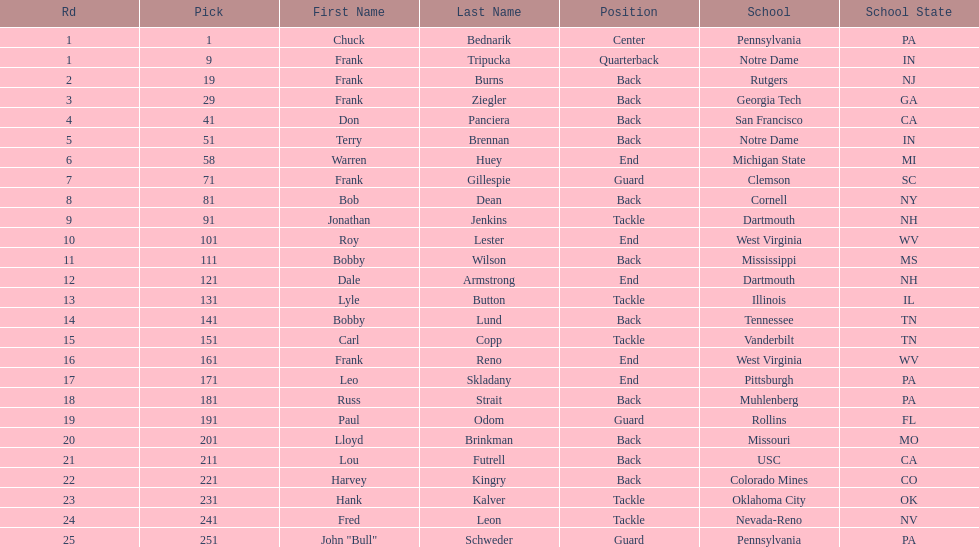Write the full table. {'header': ['Rd', 'Pick', 'First Name', 'Last Name', 'Position', 'School', 'School State'], 'rows': [['1', '1', 'Chuck', 'Bednarik', 'Center', 'Pennsylvania', 'PA'], ['1', '9', 'Frank', 'Tripucka', 'Quarterback', 'Notre Dame', 'IN'], ['2', '19', 'Frank', 'Burns', 'Back', 'Rutgers', 'NJ'], ['3', '29', 'Frank', 'Ziegler', 'Back', 'Georgia Tech', 'GA'], ['4', '41', 'Don', 'Panciera', 'Back', 'San Francisco', 'CA'], ['5', '51', 'Terry', 'Brennan', 'Back', 'Notre Dame', 'IN'], ['6', '58', 'Warren', 'Huey', 'End', 'Michigan State', 'MI'], ['7', '71', 'Frank', 'Gillespie', 'Guard', 'Clemson', 'SC'], ['8', '81', 'Bob', 'Dean', 'Back', 'Cornell', 'NY'], ['9', '91', 'Jonathan', 'Jenkins', 'Tackle', 'Dartmouth', 'NH'], ['10', '101', 'Roy', 'Lester', 'End', 'West Virginia', 'WV'], ['11', '111', 'Bobby', 'Wilson', 'Back', 'Mississippi', 'MS'], ['12', '121', 'Dale', 'Armstrong', 'End', 'Dartmouth', 'NH'], ['13', '131', 'Lyle', 'Button', 'Tackle', 'Illinois', 'IL'], ['14', '141', 'Bobby', 'Lund', 'Back', 'Tennessee', 'TN'], ['15', '151', 'Carl', 'Copp', 'Tackle', 'Vanderbilt', 'TN'], ['16', '161', 'Frank', 'Reno', 'End', 'West Virginia', 'WV'], ['17', '171', 'Leo', 'Skladany', 'End', 'Pittsburgh', 'PA'], ['18', '181', 'Russ', 'Strait', 'Back', 'Muhlenberg', 'PA'], ['19', '191', 'Paul', 'Odom', 'Guard', 'Rollins', 'FL'], ['20', '201', 'Lloyd', 'Brinkman', 'Back', 'Missouri', 'MO'], ['21', '211', 'Lou', 'Futrell', 'Back', 'USC', 'CA'], ['22', '221', 'Harvey', 'Kingry', 'Back', 'Colorado Mines', 'CO'], ['23', '231', 'Hank', 'Kalver', 'Tackle', 'Oklahoma City', 'OK'], ['24', '241', 'Fred', 'Leon', 'Tackle', 'Nevada-Reno', 'NV'], ['25', '251', 'John "Bull"', 'Schweder', 'Guard', 'Pennsylvania', 'PA']]} Highest rd number? 25. 